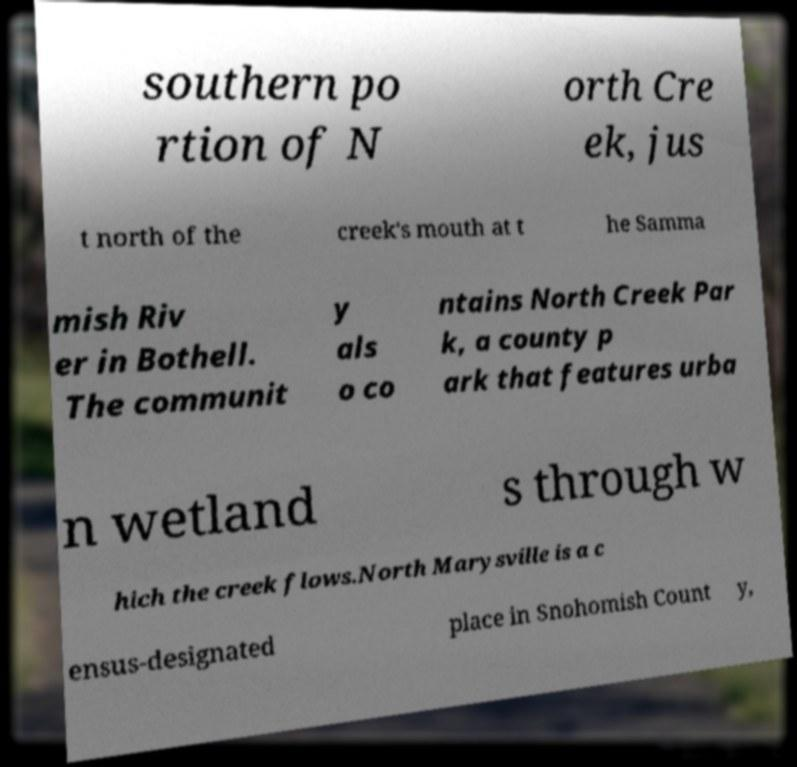Could you extract and type out the text from this image? southern po rtion of N orth Cre ek, jus t north of the creek's mouth at t he Samma mish Riv er in Bothell. The communit y als o co ntains North Creek Par k, a county p ark that features urba n wetland s through w hich the creek flows.North Marysville is a c ensus-designated place in Snohomish Count y, 